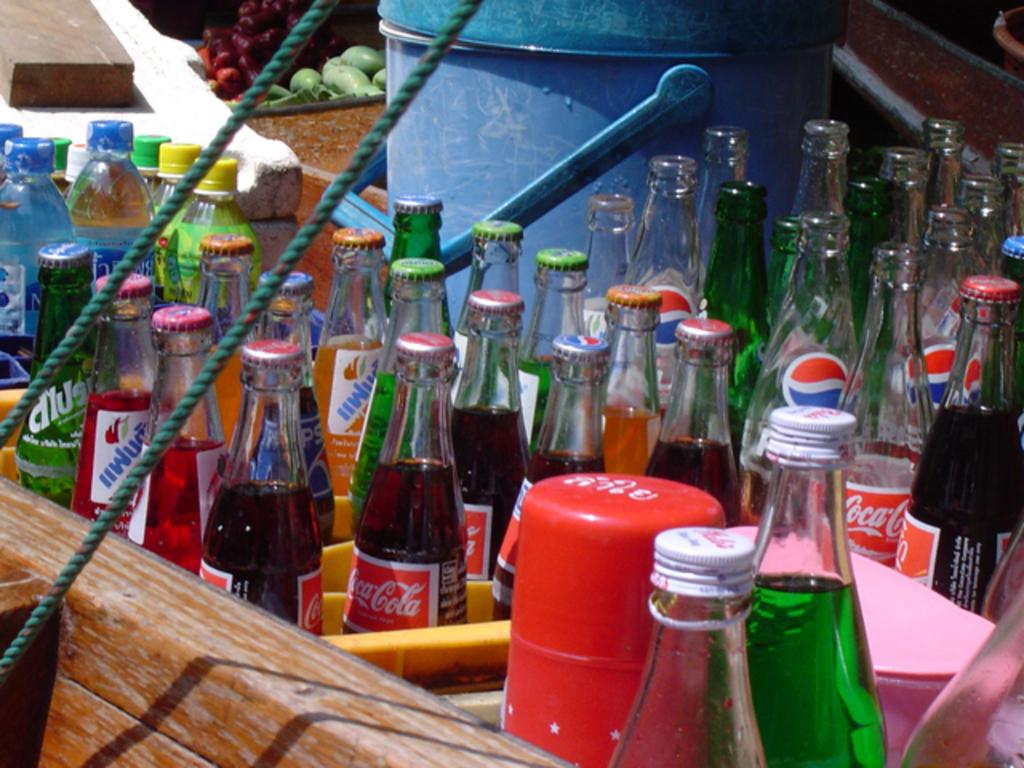<image>
Offer a succinct explanation of the picture presented. Bottles of Coca-Cola sit among other soda bottles. 